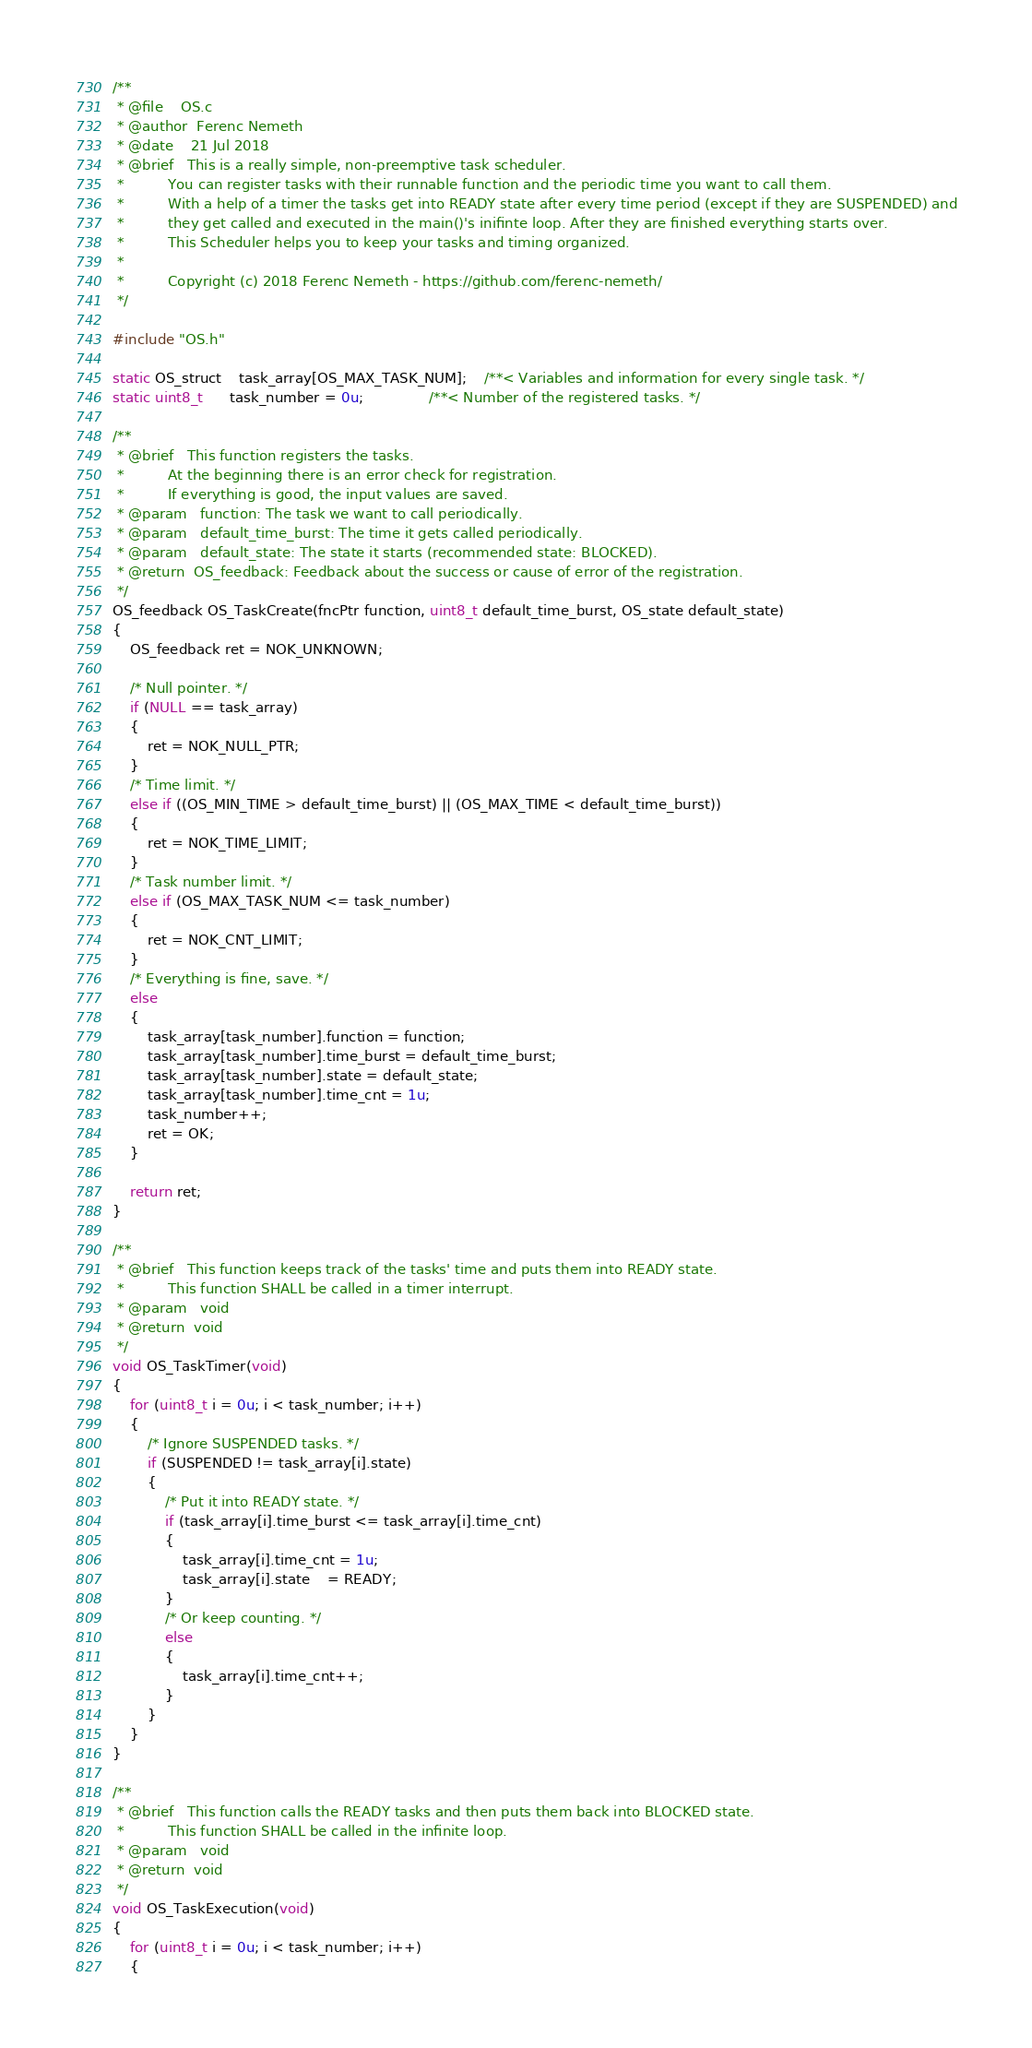<code> <loc_0><loc_0><loc_500><loc_500><_C_>/**
 * @file    OS.c
 * @author  Ferenc Nemeth
 * @date    21 Jul 2018
 * @brief   This is a really simple, non-preemptive task scheduler.
 *          You can register tasks with their runnable function and the periodic time you want to call them.
 *          With a help of a timer the tasks get into READY state after every time period (except if they are SUSPENDED) and
 *          they get called and executed in the main()'s inifinte loop. After they are finished everything starts over.
 *          This Scheduler helps you to keep your tasks and timing organized.
 *
 *          Copyright (c) 2018 Ferenc Nemeth - https://github.com/ferenc-nemeth/
 */ 

#include "OS.h"

static OS_struct    task_array[OS_MAX_TASK_NUM];    /**< Variables and information for every single task. */
static uint8_t      task_number = 0u;               /**< Number of the registered tasks. */

/**
 * @brief   This function registers the tasks.
 *          At the beginning there is an error check for registration.
 *          If everything is good, the input values are saved.
 * @param   function: The task we want to call periodically.
 * @param   default_time_burst: The time it gets called periodically.
 * @param   default_state: The state it starts (recommended state: BLOCKED).
 * @return  OS_feedback: Feedback about the success or cause of error of the registration.
 */
OS_feedback OS_TaskCreate(fncPtr function, uint8_t default_time_burst, OS_state default_state)
{
    OS_feedback ret = NOK_UNKNOWN;

    /* Null pointer. */
    if (NULL == task_array)
    {
        ret = NOK_NULL_PTR;
    }
    /* Time limit. */
    else if ((OS_MIN_TIME > default_time_burst) || (OS_MAX_TIME < default_time_burst))
    {
        ret = NOK_TIME_LIMIT;
    }
    /* Task number limit. */
    else if (OS_MAX_TASK_NUM <= task_number)
    {
        ret = NOK_CNT_LIMIT;
    }
    /* Everything is fine, save. */
    else
    {
        task_array[task_number].function = function;
        task_array[task_number].time_burst = default_time_burst;
        task_array[task_number].state = default_state;
        task_array[task_number].time_cnt = 1u;
        task_number++;
        ret = OK;
    }

    return ret;
}

/**
 * @brief   This function keeps track of the tasks' time and puts them into READY state.
 *          This function SHALL be called in a timer interrupt.
 * @param   void
 * @return  void
 */
void OS_TaskTimer(void)
{
    for (uint8_t i = 0u; i < task_number; i++)
    {
        /* Ignore SUSPENDED tasks. */
        if (SUSPENDED != task_array[i].state)
        {
            /* Put it into READY state. */
            if (task_array[i].time_burst <= task_array[i].time_cnt)
            {
                task_array[i].time_cnt = 1u;
                task_array[i].state	= READY;
            }
            /* Or keep counting. */
            else
            {
                task_array[i].time_cnt++;
            }
        }
    }
}

/**
 * @brief   This function calls the READY tasks and then puts them back into BLOCKED state.
 *          This function SHALL be called in the infinite loop.
 * @param   void
 * @return  void
 */
void OS_TaskExecution(void)
{
    for (uint8_t i = 0u; i < task_number; i++)
    {</code> 